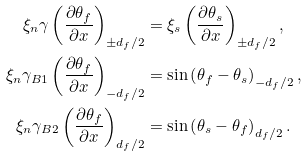Convert formula to latex. <formula><loc_0><loc_0><loc_500><loc_500>\xi _ { n } \gamma \left ( \frac { \partial \theta _ { f } } { \partial x } \right ) _ { \pm d _ { f } / 2 } & = \xi _ { s } \left ( \frac { \partial \theta _ { s } } { \partial x } \right ) _ { \pm d _ { f } / 2 } , \\ \xi _ { n } \gamma _ { B 1 } \left ( \frac { \partial \theta _ { f } } { \partial x } \right ) _ { - d _ { f } / 2 } & = \sin \left ( \theta _ { f } - \theta _ { s } \right ) _ { - d _ { f } / 2 } , \\ \xi _ { n } \gamma _ { B 2 } \left ( \frac { \partial \theta _ { f } } { \partial x } \right ) _ { d _ { f } / 2 } & = \sin \left ( \theta _ { s } - \theta _ { f } \right ) _ { d _ { f } / 2 } .</formula> 